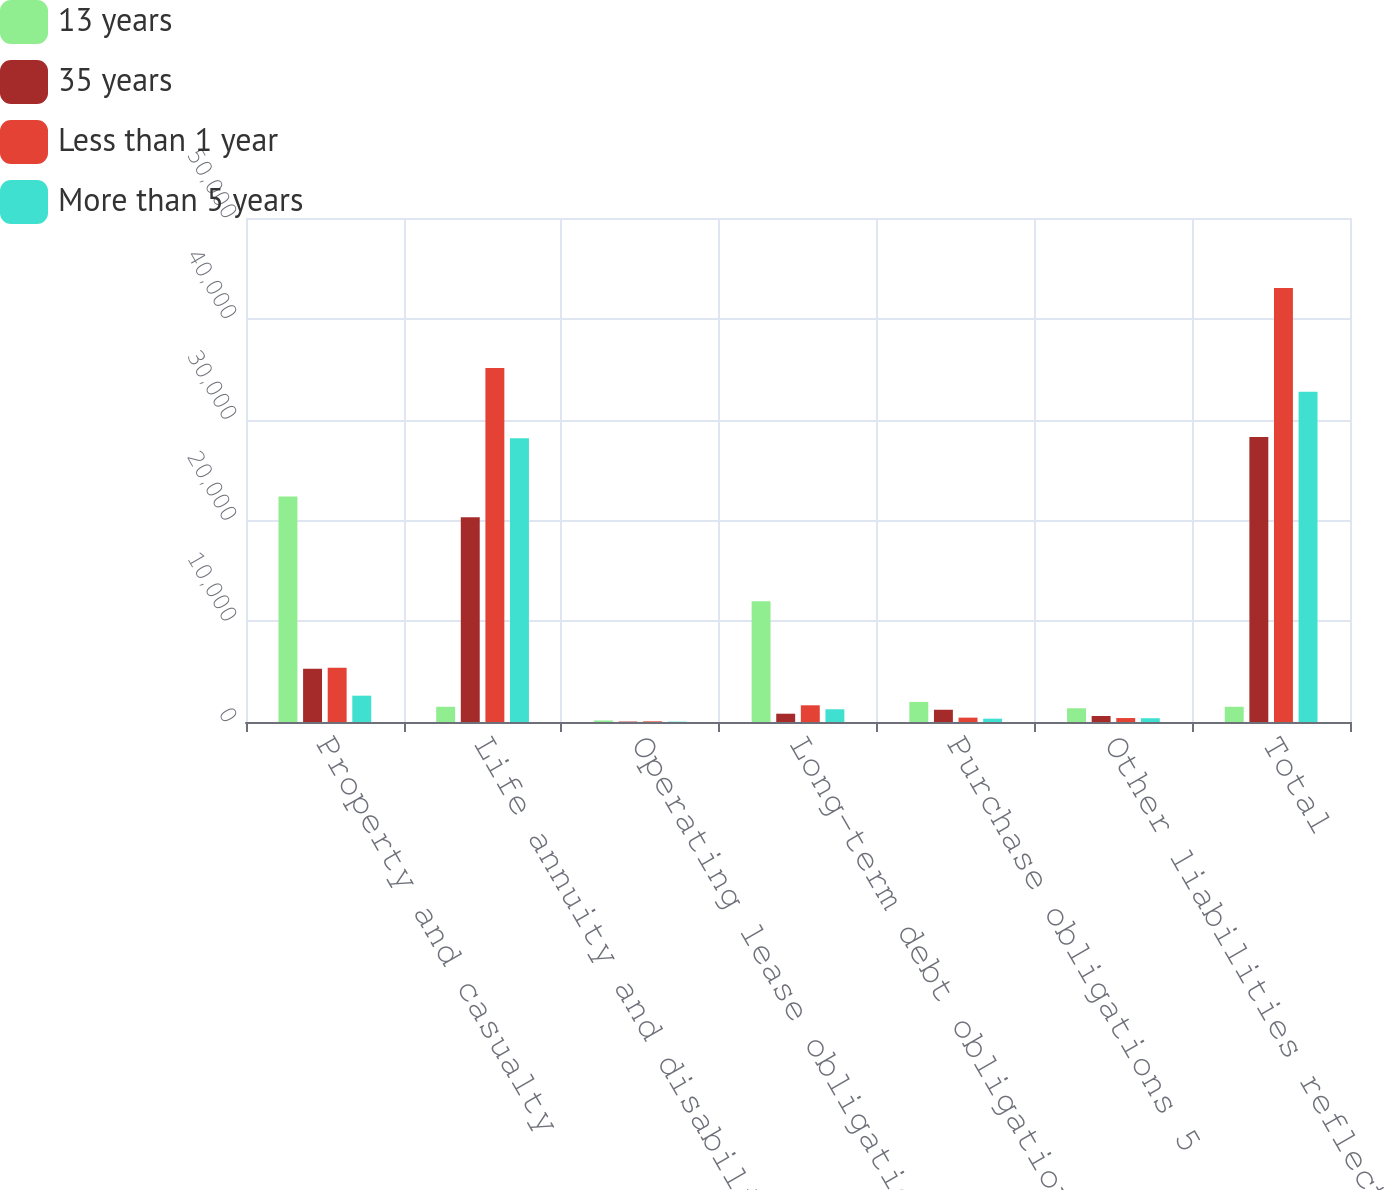Convert chart. <chart><loc_0><loc_0><loc_500><loc_500><stacked_bar_chart><ecel><fcel>Property and casualty<fcel>Life annuity and disability<fcel>Operating lease obligations 3<fcel>Long-term debt obligations 4<fcel>Purchase obligations 5<fcel>Other liabilities reflected on<fcel>Total<nl><fcel>13 years<fcel>22362<fcel>1509.5<fcel>154<fcel>11986<fcel>1990<fcel>1362<fcel>1509.5<nl><fcel>35 years<fcel>5282<fcel>20308<fcel>42<fcel>822<fcel>1215<fcel>593<fcel>28262<nl><fcel>Less than 1 year<fcel>5377<fcel>35122<fcel>64<fcel>1657<fcel>433<fcel>392<fcel>43045<nl><fcel>More than 5 years<fcel>2611<fcel>28151<fcel>36<fcel>1264<fcel>331<fcel>376<fcel>32769<nl></chart> 